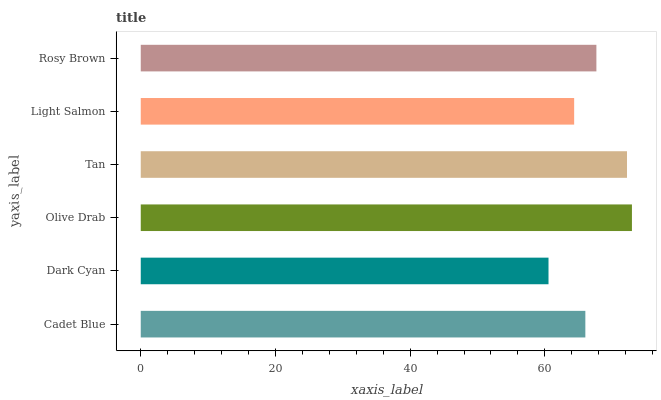Is Dark Cyan the minimum?
Answer yes or no. Yes. Is Olive Drab the maximum?
Answer yes or no. Yes. Is Olive Drab the minimum?
Answer yes or no. No. Is Dark Cyan the maximum?
Answer yes or no. No. Is Olive Drab greater than Dark Cyan?
Answer yes or no. Yes. Is Dark Cyan less than Olive Drab?
Answer yes or no. Yes. Is Dark Cyan greater than Olive Drab?
Answer yes or no. No. Is Olive Drab less than Dark Cyan?
Answer yes or no. No. Is Rosy Brown the high median?
Answer yes or no. Yes. Is Cadet Blue the low median?
Answer yes or no. Yes. Is Dark Cyan the high median?
Answer yes or no. No. Is Light Salmon the low median?
Answer yes or no. No. 